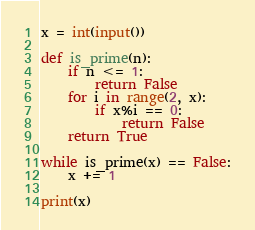<code> <loc_0><loc_0><loc_500><loc_500><_Python_>x = int(input())

def is_prime(n):
    if n <= 1:
        return False
    for i in range(2, x):
        if x%i == 0:
            return False
    return True

while is_prime(x) == False:
    x += 1

print(x)</code> 